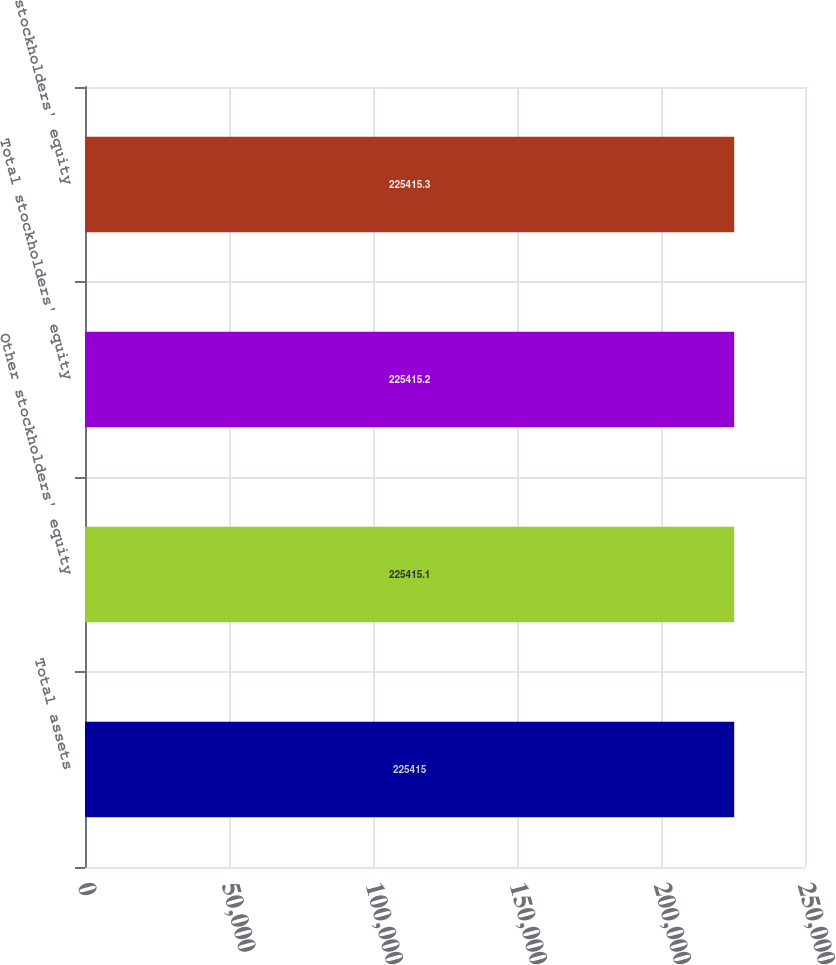Convert chart to OTSL. <chart><loc_0><loc_0><loc_500><loc_500><bar_chart><fcel>Total assets<fcel>Other stockholders' equity<fcel>Total stockholders' equity<fcel>stockholders' equity<nl><fcel>225415<fcel>225415<fcel>225415<fcel>225415<nl></chart> 